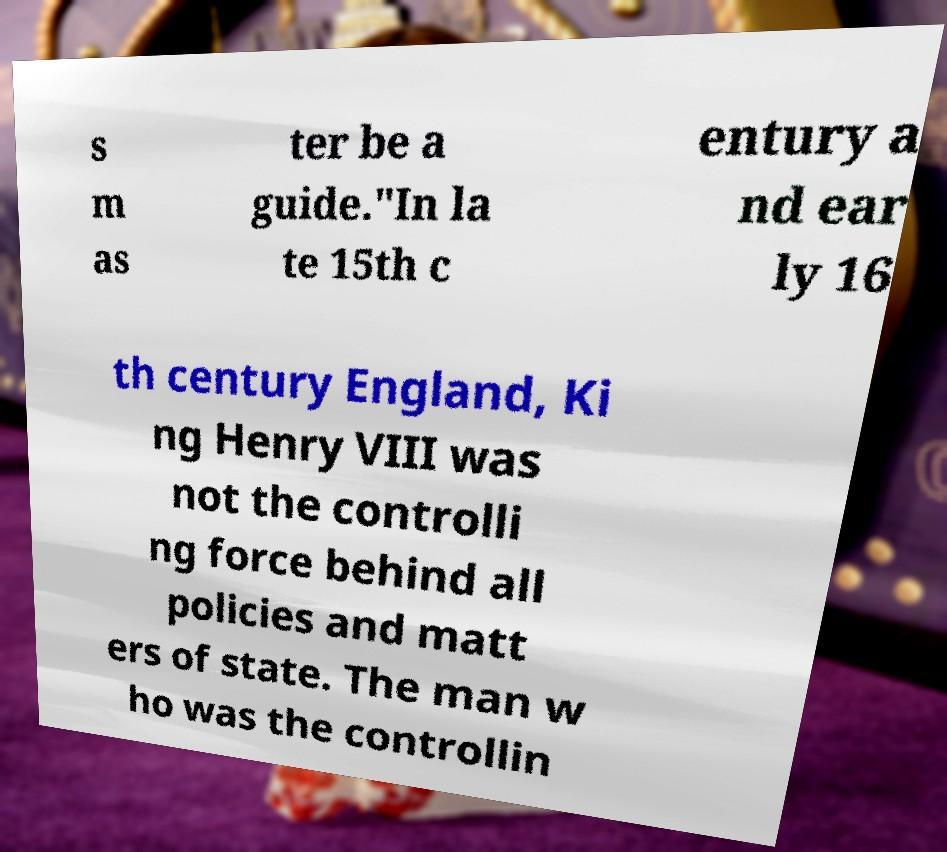Could you extract and type out the text from this image? s m as ter be a guide."In la te 15th c entury a nd ear ly 16 th century England, Ki ng Henry VIII was not the controlli ng force behind all policies and matt ers of state. The man w ho was the controllin 